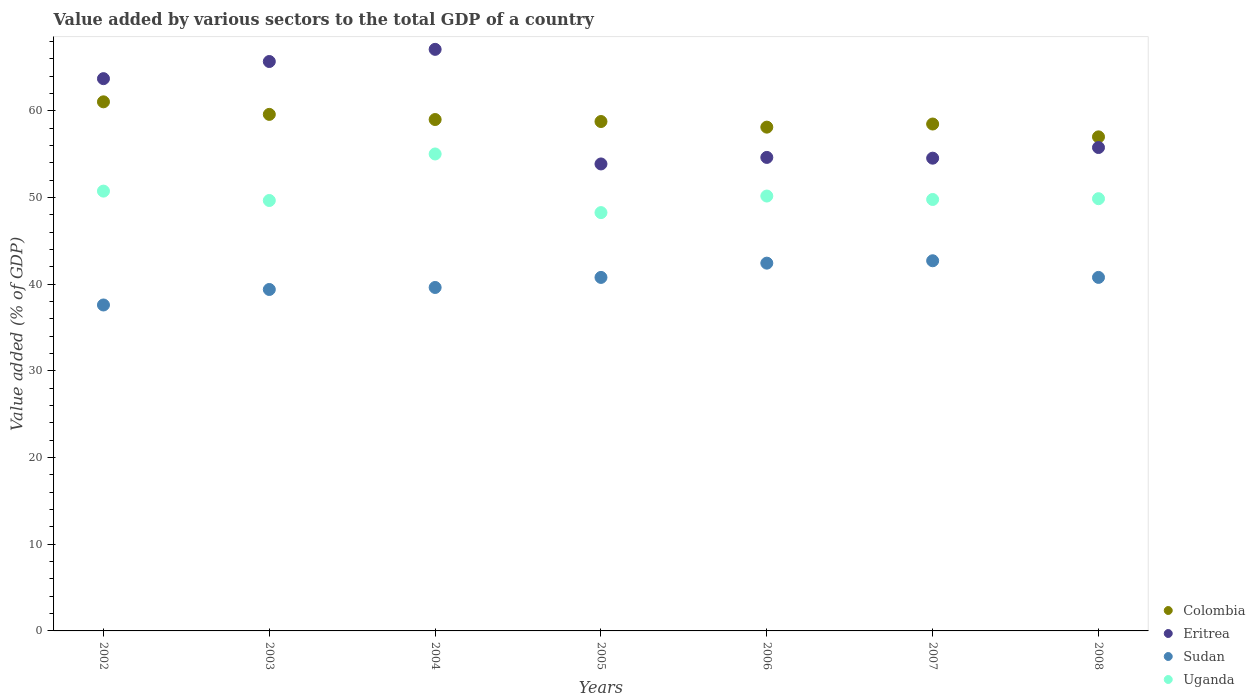How many different coloured dotlines are there?
Ensure brevity in your answer.  4. Is the number of dotlines equal to the number of legend labels?
Ensure brevity in your answer.  Yes. What is the value added by various sectors to the total GDP in Uganda in 2002?
Provide a succinct answer. 50.74. Across all years, what is the maximum value added by various sectors to the total GDP in Sudan?
Keep it short and to the point. 42.7. Across all years, what is the minimum value added by various sectors to the total GDP in Colombia?
Your answer should be very brief. 57. What is the total value added by various sectors to the total GDP in Sudan in the graph?
Your answer should be compact. 283.31. What is the difference between the value added by various sectors to the total GDP in Sudan in 2004 and that in 2006?
Offer a very short reply. -2.81. What is the difference between the value added by various sectors to the total GDP in Eritrea in 2002 and the value added by various sectors to the total GDP in Uganda in 2007?
Offer a very short reply. 13.94. What is the average value added by various sectors to the total GDP in Colombia per year?
Make the answer very short. 58.85. In the year 2007, what is the difference between the value added by various sectors to the total GDP in Sudan and value added by various sectors to the total GDP in Colombia?
Make the answer very short. -15.77. In how many years, is the value added by various sectors to the total GDP in Eritrea greater than 48 %?
Give a very brief answer. 7. What is the ratio of the value added by various sectors to the total GDP in Colombia in 2003 to that in 2005?
Provide a succinct answer. 1.01. Is the difference between the value added by various sectors to the total GDP in Sudan in 2003 and 2007 greater than the difference between the value added by various sectors to the total GDP in Colombia in 2003 and 2007?
Provide a succinct answer. No. What is the difference between the highest and the second highest value added by various sectors to the total GDP in Uganda?
Offer a very short reply. 4.28. What is the difference between the highest and the lowest value added by various sectors to the total GDP in Uganda?
Your answer should be compact. 6.76. Is the sum of the value added by various sectors to the total GDP in Sudan in 2002 and 2004 greater than the maximum value added by various sectors to the total GDP in Colombia across all years?
Your answer should be compact. Yes. Is it the case that in every year, the sum of the value added by various sectors to the total GDP in Colombia and value added by various sectors to the total GDP in Eritrea  is greater than the sum of value added by various sectors to the total GDP in Sudan and value added by various sectors to the total GDP in Uganda?
Provide a succinct answer. No. Is it the case that in every year, the sum of the value added by various sectors to the total GDP in Eritrea and value added by various sectors to the total GDP in Sudan  is greater than the value added by various sectors to the total GDP in Colombia?
Your answer should be very brief. Yes. What is the difference between two consecutive major ticks on the Y-axis?
Provide a short and direct response. 10. Where does the legend appear in the graph?
Offer a terse response. Bottom right. How many legend labels are there?
Provide a short and direct response. 4. How are the legend labels stacked?
Provide a succinct answer. Vertical. What is the title of the graph?
Give a very brief answer. Value added by various sectors to the total GDP of a country. What is the label or title of the Y-axis?
Provide a short and direct response. Value added (% of GDP). What is the Value added (% of GDP) in Colombia in 2002?
Offer a terse response. 61.04. What is the Value added (% of GDP) of Eritrea in 2002?
Offer a terse response. 63.71. What is the Value added (% of GDP) in Sudan in 2002?
Your answer should be very brief. 37.6. What is the Value added (% of GDP) in Uganda in 2002?
Give a very brief answer. 50.74. What is the Value added (% of GDP) in Colombia in 2003?
Ensure brevity in your answer.  59.59. What is the Value added (% of GDP) of Eritrea in 2003?
Offer a terse response. 65.69. What is the Value added (% of GDP) of Sudan in 2003?
Your answer should be compact. 39.39. What is the Value added (% of GDP) of Uganda in 2003?
Offer a very short reply. 49.66. What is the Value added (% of GDP) in Colombia in 2004?
Your answer should be compact. 59. What is the Value added (% of GDP) of Eritrea in 2004?
Make the answer very short. 67.09. What is the Value added (% of GDP) in Sudan in 2004?
Keep it short and to the point. 39.62. What is the Value added (% of GDP) of Uganda in 2004?
Keep it short and to the point. 55.02. What is the Value added (% of GDP) in Colombia in 2005?
Provide a short and direct response. 58.77. What is the Value added (% of GDP) of Eritrea in 2005?
Your response must be concise. 53.87. What is the Value added (% of GDP) of Sudan in 2005?
Provide a short and direct response. 40.78. What is the Value added (% of GDP) in Uganda in 2005?
Keep it short and to the point. 48.26. What is the Value added (% of GDP) of Colombia in 2006?
Your response must be concise. 58.12. What is the Value added (% of GDP) in Eritrea in 2006?
Make the answer very short. 54.63. What is the Value added (% of GDP) of Sudan in 2006?
Provide a short and direct response. 42.43. What is the Value added (% of GDP) in Uganda in 2006?
Your answer should be very brief. 50.17. What is the Value added (% of GDP) in Colombia in 2007?
Keep it short and to the point. 58.48. What is the Value added (% of GDP) of Eritrea in 2007?
Your response must be concise. 54.54. What is the Value added (% of GDP) in Sudan in 2007?
Offer a terse response. 42.7. What is the Value added (% of GDP) in Uganda in 2007?
Your response must be concise. 49.77. What is the Value added (% of GDP) of Colombia in 2008?
Your response must be concise. 57. What is the Value added (% of GDP) of Eritrea in 2008?
Provide a succinct answer. 55.77. What is the Value added (% of GDP) in Sudan in 2008?
Keep it short and to the point. 40.78. What is the Value added (% of GDP) of Uganda in 2008?
Offer a terse response. 49.86. Across all years, what is the maximum Value added (% of GDP) in Colombia?
Your answer should be compact. 61.04. Across all years, what is the maximum Value added (% of GDP) in Eritrea?
Your answer should be compact. 67.09. Across all years, what is the maximum Value added (% of GDP) in Sudan?
Keep it short and to the point. 42.7. Across all years, what is the maximum Value added (% of GDP) of Uganda?
Ensure brevity in your answer.  55.02. Across all years, what is the minimum Value added (% of GDP) of Colombia?
Ensure brevity in your answer.  57. Across all years, what is the minimum Value added (% of GDP) in Eritrea?
Offer a very short reply. 53.87. Across all years, what is the minimum Value added (% of GDP) in Sudan?
Ensure brevity in your answer.  37.6. Across all years, what is the minimum Value added (% of GDP) in Uganda?
Offer a terse response. 48.26. What is the total Value added (% of GDP) in Colombia in the graph?
Offer a terse response. 411.98. What is the total Value added (% of GDP) in Eritrea in the graph?
Provide a short and direct response. 415.29. What is the total Value added (% of GDP) of Sudan in the graph?
Provide a succinct answer. 283.31. What is the total Value added (% of GDP) in Uganda in the graph?
Offer a very short reply. 353.48. What is the difference between the Value added (% of GDP) in Colombia in 2002 and that in 2003?
Provide a short and direct response. 1.45. What is the difference between the Value added (% of GDP) in Eritrea in 2002 and that in 2003?
Provide a succinct answer. -1.98. What is the difference between the Value added (% of GDP) of Sudan in 2002 and that in 2003?
Offer a terse response. -1.79. What is the difference between the Value added (% of GDP) in Uganda in 2002 and that in 2003?
Offer a very short reply. 1.08. What is the difference between the Value added (% of GDP) of Colombia in 2002 and that in 2004?
Provide a succinct answer. 2.04. What is the difference between the Value added (% of GDP) of Eritrea in 2002 and that in 2004?
Provide a succinct answer. -3.38. What is the difference between the Value added (% of GDP) in Sudan in 2002 and that in 2004?
Offer a very short reply. -2.02. What is the difference between the Value added (% of GDP) in Uganda in 2002 and that in 2004?
Your response must be concise. -4.28. What is the difference between the Value added (% of GDP) in Colombia in 2002 and that in 2005?
Offer a terse response. 2.27. What is the difference between the Value added (% of GDP) of Eritrea in 2002 and that in 2005?
Give a very brief answer. 9.84. What is the difference between the Value added (% of GDP) of Sudan in 2002 and that in 2005?
Keep it short and to the point. -3.18. What is the difference between the Value added (% of GDP) in Uganda in 2002 and that in 2005?
Make the answer very short. 2.48. What is the difference between the Value added (% of GDP) in Colombia in 2002 and that in 2006?
Your answer should be compact. 2.92. What is the difference between the Value added (% of GDP) in Eritrea in 2002 and that in 2006?
Provide a short and direct response. 9.09. What is the difference between the Value added (% of GDP) of Sudan in 2002 and that in 2006?
Make the answer very short. -4.83. What is the difference between the Value added (% of GDP) in Uganda in 2002 and that in 2006?
Make the answer very short. 0.57. What is the difference between the Value added (% of GDP) of Colombia in 2002 and that in 2007?
Give a very brief answer. 2.56. What is the difference between the Value added (% of GDP) of Eritrea in 2002 and that in 2007?
Keep it short and to the point. 9.17. What is the difference between the Value added (% of GDP) in Sudan in 2002 and that in 2007?
Make the answer very short. -5.1. What is the difference between the Value added (% of GDP) in Uganda in 2002 and that in 2007?
Your response must be concise. 0.97. What is the difference between the Value added (% of GDP) of Colombia in 2002 and that in 2008?
Ensure brevity in your answer.  4.04. What is the difference between the Value added (% of GDP) of Eritrea in 2002 and that in 2008?
Your response must be concise. 7.95. What is the difference between the Value added (% of GDP) in Sudan in 2002 and that in 2008?
Offer a terse response. -3.18. What is the difference between the Value added (% of GDP) in Uganda in 2002 and that in 2008?
Offer a very short reply. 0.87. What is the difference between the Value added (% of GDP) in Colombia in 2003 and that in 2004?
Offer a very short reply. 0.59. What is the difference between the Value added (% of GDP) in Eritrea in 2003 and that in 2004?
Your answer should be compact. -1.4. What is the difference between the Value added (% of GDP) in Sudan in 2003 and that in 2004?
Make the answer very short. -0.23. What is the difference between the Value added (% of GDP) of Uganda in 2003 and that in 2004?
Provide a short and direct response. -5.37. What is the difference between the Value added (% of GDP) in Colombia in 2003 and that in 2005?
Your response must be concise. 0.82. What is the difference between the Value added (% of GDP) in Eritrea in 2003 and that in 2005?
Keep it short and to the point. 11.82. What is the difference between the Value added (% of GDP) of Sudan in 2003 and that in 2005?
Ensure brevity in your answer.  -1.39. What is the difference between the Value added (% of GDP) in Uganda in 2003 and that in 2005?
Provide a short and direct response. 1.4. What is the difference between the Value added (% of GDP) in Colombia in 2003 and that in 2006?
Make the answer very short. 1.47. What is the difference between the Value added (% of GDP) of Eritrea in 2003 and that in 2006?
Offer a very short reply. 11.06. What is the difference between the Value added (% of GDP) in Sudan in 2003 and that in 2006?
Your response must be concise. -3.04. What is the difference between the Value added (% of GDP) in Uganda in 2003 and that in 2006?
Keep it short and to the point. -0.51. What is the difference between the Value added (% of GDP) of Colombia in 2003 and that in 2007?
Give a very brief answer. 1.11. What is the difference between the Value added (% of GDP) in Eritrea in 2003 and that in 2007?
Your response must be concise. 11.15. What is the difference between the Value added (% of GDP) of Sudan in 2003 and that in 2007?
Provide a succinct answer. -3.31. What is the difference between the Value added (% of GDP) in Uganda in 2003 and that in 2007?
Provide a succinct answer. -0.12. What is the difference between the Value added (% of GDP) of Colombia in 2003 and that in 2008?
Provide a short and direct response. 2.59. What is the difference between the Value added (% of GDP) of Eritrea in 2003 and that in 2008?
Provide a succinct answer. 9.92. What is the difference between the Value added (% of GDP) in Sudan in 2003 and that in 2008?
Make the answer very short. -1.39. What is the difference between the Value added (% of GDP) in Uganda in 2003 and that in 2008?
Offer a very short reply. -0.21. What is the difference between the Value added (% of GDP) of Colombia in 2004 and that in 2005?
Provide a succinct answer. 0.23. What is the difference between the Value added (% of GDP) of Eritrea in 2004 and that in 2005?
Keep it short and to the point. 13.22. What is the difference between the Value added (% of GDP) in Sudan in 2004 and that in 2005?
Provide a succinct answer. -1.16. What is the difference between the Value added (% of GDP) of Uganda in 2004 and that in 2005?
Give a very brief answer. 6.76. What is the difference between the Value added (% of GDP) of Colombia in 2004 and that in 2006?
Your response must be concise. 0.88. What is the difference between the Value added (% of GDP) of Eritrea in 2004 and that in 2006?
Offer a very short reply. 12.47. What is the difference between the Value added (% of GDP) of Sudan in 2004 and that in 2006?
Keep it short and to the point. -2.81. What is the difference between the Value added (% of GDP) of Uganda in 2004 and that in 2006?
Ensure brevity in your answer.  4.85. What is the difference between the Value added (% of GDP) of Colombia in 2004 and that in 2007?
Your answer should be compact. 0.52. What is the difference between the Value added (% of GDP) of Eritrea in 2004 and that in 2007?
Give a very brief answer. 12.55. What is the difference between the Value added (% of GDP) of Sudan in 2004 and that in 2007?
Your response must be concise. -3.08. What is the difference between the Value added (% of GDP) of Uganda in 2004 and that in 2007?
Your answer should be compact. 5.25. What is the difference between the Value added (% of GDP) of Colombia in 2004 and that in 2008?
Your response must be concise. 2. What is the difference between the Value added (% of GDP) of Eritrea in 2004 and that in 2008?
Provide a succinct answer. 11.32. What is the difference between the Value added (% of GDP) in Sudan in 2004 and that in 2008?
Offer a terse response. -1.16. What is the difference between the Value added (% of GDP) of Uganda in 2004 and that in 2008?
Your answer should be very brief. 5.16. What is the difference between the Value added (% of GDP) of Colombia in 2005 and that in 2006?
Your answer should be very brief. 0.65. What is the difference between the Value added (% of GDP) in Eritrea in 2005 and that in 2006?
Provide a short and direct response. -0.75. What is the difference between the Value added (% of GDP) in Sudan in 2005 and that in 2006?
Give a very brief answer. -1.65. What is the difference between the Value added (% of GDP) of Uganda in 2005 and that in 2006?
Give a very brief answer. -1.91. What is the difference between the Value added (% of GDP) in Colombia in 2005 and that in 2007?
Offer a very short reply. 0.29. What is the difference between the Value added (% of GDP) in Eritrea in 2005 and that in 2007?
Your answer should be very brief. -0.67. What is the difference between the Value added (% of GDP) of Sudan in 2005 and that in 2007?
Provide a succinct answer. -1.92. What is the difference between the Value added (% of GDP) of Uganda in 2005 and that in 2007?
Ensure brevity in your answer.  -1.52. What is the difference between the Value added (% of GDP) in Colombia in 2005 and that in 2008?
Provide a succinct answer. 1.77. What is the difference between the Value added (% of GDP) of Eritrea in 2005 and that in 2008?
Ensure brevity in your answer.  -1.89. What is the difference between the Value added (% of GDP) in Sudan in 2005 and that in 2008?
Ensure brevity in your answer.  -0. What is the difference between the Value added (% of GDP) of Uganda in 2005 and that in 2008?
Offer a very short reply. -1.61. What is the difference between the Value added (% of GDP) of Colombia in 2006 and that in 2007?
Provide a short and direct response. -0.36. What is the difference between the Value added (% of GDP) in Eritrea in 2006 and that in 2007?
Your answer should be very brief. 0.09. What is the difference between the Value added (% of GDP) of Sudan in 2006 and that in 2007?
Make the answer very short. -0.27. What is the difference between the Value added (% of GDP) of Uganda in 2006 and that in 2007?
Your answer should be compact. 0.4. What is the difference between the Value added (% of GDP) in Colombia in 2006 and that in 2008?
Your response must be concise. 1.12. What is the difference between the Value added (% of GDP) of Eritrea in 2006 and that in 2008?
Offer a very short reply. -1.14. What is the difference between the Value added (% of GDP) of Sudan in 2006 and that in 2008?
Provide a succinct answer. 1.64. What is the difference between the Value added (% of GDP) of Uganda in 2006 and that in 2008?
Your response must be concise. 0.31. What is the difference between the Value added (% of GDP) of Colombia in 2007 and that in 2008?
Offer a very short reply. 1.48. What is the difference between the Value added (% of GDP) of Eritrea in 2007 and that in 2008?
Your answer should be very brief. -1.23. What is the difference between the Value added (% of GDP) of Sudan in 2007 and that in 2008?
Offer a terse response. 1.92. What is the difference between the Value added (% of GDP) in Uganda in 2007 and that in 2008?
Provide a succinct answer. -0.09. What is the difference between the Value added (% of GDP) of Colombia in 2002 and the Value added (% of GDP) of Eritrea in 2003?
Provide a short and direct response. -4.65. What is the difference between the Value added (% of GDP) of Colombia in 2002 and the Value added (% of GDP) of Sudan in 2003?
Make the answer very short. 21.65. What is the difference between the Value added (% of GDP) of Colombia in 2002 and the Value added (% of GDP) of Uganda in 2003?
Make the answer very short. 11.38. What is the difference between the Value added (% of GDP) in Eritrea in 2002 and the Value added (% of GDP) in Sudan in 2003?
Provide a short and direct response. 24.32. What is the difference between the Value added (% of GDP) of Eritrea in 2002 and the Value added (% of GDP) of Uganda in 2003?
Your response must be concise. 14.06. What is the difference between the Value added (% of GDP) of Sudan in 2002 and the Value added (% of GDP) of Uganda in 2003?
Your answer should be compact. -12.05. What is the difference between the Value added (% of GDP) of Colombia in 2002 and the Value added (% of GDP) of Eritrea in 2004?
Your answer should be compact. -6.05. What is the difference between the Value added (% of GDP) in Colombia in 2002 and the Value added (% of GDP) in Sudan in 2004?
Keep it short and to the point. 21.42. What is the difference between the Value added (% of GDP) of Colombia in 2002 and the Value added (% of GDP) of Uganda in 2004?
Your answer should be very brief. 6.02. What is the difference between the Value added (% of GDP) of Eritrea in 2002 and the Value added (% of GDP) of Sudan in 2004?
Make the answer very short. 24.09. What is the difference between the Value added (% of GDP) of Eritrea in 2002 and the Value added (% of GDP) of Uganda in 2004?
Give a very brief answer. 8.69. What is the difference between the Value added (% of GDP) in Sudan in 2002 and the Value added (% of GDP) in Uganda in 2004?
Make the answer very short. -17.42. What is the difference between the Value added (% of GDP) of Colombia in 2002 and the Value added (% of GDP) of Eritrea in 2005?
Ensure brevity in your answer.  7.17. What is the difference between the Value added (% of GDP) of Colombia in 2002 and the Value added (% of GDP) of Sudan in 2005?
Provide a succinct answer. 20.26. What is the difference between the Value added (% of GDP) of Colombia in 2002 and the Value added (% of GDP) of Uganda in 2005?
Your response must be concise. 12.78. What is the difference between the Value added (% of GDP) of Eritrea in 2002 and the Value added (% of GDP) of Sudan in 2005?
Your answer should be compact. 22.93. What is the difference between the Value added (% of GDP) of Eritrea in 2002 and the Value added (% of GDP) of Uganda in 2005?
Keep it short and to the point. 15.45. What is the difference between the Value added (% of GDP) in Sudan in 2002 and the Value added (% of GDP) in Uganda in 2005?
Your answer should be compact. -10.66. What is the difference between the Value added (% of GDP) in Colombia in 2002 and the Value added (% of GDP) in Eritrea in 2006?
Keep it short and to the point. 6.41. What is the difference between the Value added (% of GDP) of Colombia in 2002 and the Value added (% of GDP) of Sudan in 2006?
Provide a succinct answer. 18.61. What is the difference between the Value added (% of GDP) of Colombia in 2002 and the Value added (% of GDP) of Uganda in 2006?
Provide a short and direct response. 10.87. What is the difference between the Value added (% of GDP) of Eritrea in 2002 and the Value added (% of GDP) of Sudan in 2006?
Provide a short and direct response. 21.28. What is the difference between the Value added (% of GDP) of Eritrea in 2002 and the Value added (% of GDP) of Uganda in 2006?
Your answer should be compact. 13.54. What is the difference between the Value added (% of GDP) in Sudan in 2002 and the Value added (% of GDP) in Uganda in 2006?
Provide a succinct answer. -12.57. What is the difference between the Value added (% of GDP) of Colombia in 2002 and the Value added (% of GDP) of Eritrea in 2007?
Provide a succinct answer. 6.5. What is the difference between the Value added (% of GDP) of Colombia in 2002 and the Value added (% of GDP) of Sudan in 2007?
Your response must be concise. 18.34. What is the difference between the Value added (% of GDP) of Colombia in 2002 and the Value added (% of GDP) of Uganda in 2007?
Keep it short and to the point. 11.27. What is the difference between the Value added (% of GDP) in Eritrea in 2002 and the Value added (% of GDP) in Sudan in 2007?
Provide a succinct answer. 21.01. What is the difference between the Value added (% of GDP) in Eritrea in 2002 and the Value added (% of GDP) in Uganda in 2007?
Offer a terse response. 13.94. What is the difference between the Value added (% of GDP) of Sudan in 2002 and the Value added (% of GDP) of Uganda in 2007?
Your response must be concise. -12.17. What is the difference between the Value added (% of GDP) in Colombia in 2002 and the Value added (% of GDP) in Eritrea in 2008?
Make the answer very short. 5.27. What is the difference between the Value added (% of GDP) in Colombia in 2002 and the Value added (% of GDP) in Sudan in 2008?
Provide a succinct answer. 20.25. What is the difference between the Value added (% of GDP) of Colombia in 2002 and the Value added (% of GDP) of Uganda in 2008?
Provide a succinct answer. 11.17. What is the difference between the Value added (% of GDP) in Eritrea in 2002 and the Value added (% of GDP) in Sudan in 2008?
Give a very brief answer. 22.93. What is the difference between the Value added (% of GDP) in Eritrea in 2002 and the Value added (% of GDP) in Uganda in 2008?
Provide a short and direct response. 13.85. What is the difference between the Value added (% of GDP) of Sudan in 2002 and the Value added (% of GDP) of Uganda in 2008?
Provide a succinct answer. -12.26. What is the difference between the Value added (% of GDP) of Colombia in 2003 and the Value added (% of GDP) of Eritrea in 2004?
Your response must be concise. -7.5. What is the difference between the Value added (% of GDP) in Colombia in 2003 and the Value added (% of GDP) in Sudan in 2004?
Your answer should be compact. 19.97. What is the difference between the Value added (% of GDP) of Colombia in 2003 and the Value added (% of GDP) of Uganda in 2004?
Your answer should be very brief. 4.57. What is the difference between the Value added (% of GDP) of Eritrea in 2003 and the Value added (% of GDP) of Sudan in 2004?
Your response must be concise. 26.07. What is the difference between the Value added (% of GDP) of Eritrea in 2003 and the Value added (% of GDP) of Uganda in 2004?
Ensure brevity in your answer.  10.67. What is the difference between the Value added (% of GDP) of Sudan in 2003 and the Value added (% of GDP) of Uganda in 2004?
Your answer should be very brief. -15.63. What is the difference between the Value added (% of GDP) of Colombia in 2003 and the Value added (% of GDP) of Eritrea in 2005?
Make the answer very short. 5.72. What is the difference between the Value added (% of GDP) of Colombia in 2003 and the Value added (% of GDP) of Sudan in 2005?
Your answer should be very brief. 18.81. What is the difference between the Value added (% of GDP) in Colombia in 2003 and the Value added (% of GDP) in Uganda in 2005?
Your answer should be very brief. 11.33. What is the difference between the Value added (% of GDP) of Eritrea in 2003 and the Value added (% of GDP) of Sudan in 2005?
Provide a short and direct response. 24.91. What is the difference between the Value added (% of GDP) of Eritrea in 2003 and the Value added (% of GDP) of Uganda in 2005?
Ensure brevity in your answer.  17.43. What is the difference between the Value added (% of GDP) of Sudan in 2003 and the Value added (% of GDP) of Uganda in 2005?
Offer a terse response. -8.87. What is the difference between the Value added (% of GDP) of Colombia in 2003 and the Value added (% of GDP) of Eritrea in 2006?
Provide a succinct answer. 4.96. What is the difference between the Value added (% of GDP) in Colombia in 2003 and the Value added (% of GDP) in Sudan in 2006?
Provide a succinct answer. 17.16. What is the difference between the Value added (% of GDP) in Colombia in 2003 and the Value added (% of GDP) in Uganda in 2006?
Ensure brevity in your answer.  9.42. What is the difference between the Value added (% of GDP) of Eritrea in 2003 and the Value added (% of GDP) of Sudan in 2006?
Make the answer very short. 23.26. What is the difference between the Value added (% of GDP) in Eritrea in 2003 and the Value added (% of GDP) in Uganda in 2006?
Keep it short and to the point. 15.52. What is the difference between the Value added (% of GDP) in Sudan in 2003 and the Value added (% of GDP) in Uganda in 2006?
Give a very brief answer. -10.78. What is the difference between the Value added (% of GDP) of Colombia in 2003 and the Value added (% of GDP) of Eritrea in 2007?
Provide a succinct answer. 5.05. What is the difference between the Value added (% of GDP) of Colombia in 2003 and the Value added (% of GDP) of Sudan in 2007?
Your answer should be very brief. 16.89. What is the difference between the Value added (% of GDP) in Colombia in 2003 and the Value added (% of GDP) in Uganda in 2007?
Provide a short and direct response. 9.82. What is the difference between the Value added (% of GDP) in Eritrea in 2003 and the Value added (% of GDP) in Sudan in 2007?
Offer a very short reply. 22.99. What is the difference between the Value added (% of GDP) of Eritrea in 2003 and the Value added (% of GDP) of Uganda in 2007?
Keep it short and to the point. 15.92. What is the difference between the Value added (% of GDP) in Sudan in 2003 and the Value added (% of GDP) in Uganda in 2007?
Provide a succinct answer. -10.38. What is the difference between the Value added (% of GDP) in Colombia in 2003 and the Value added (% of GDP) in Eritrea in 2008?
Ensure brevity in your answer.  3.82. What is the difference between the Value added (% of GDP) in Colombia in 2003 and the Value added (% of GDP) in Sudan in 2008?
Give a very brief answer. 18.81. What is the difference between the Value added (% of GDP) of Colombia in 2003 and the Value added (% of GDP) of Uganda in 2008?
Provide a short and direct response. 9.73. What is the difference between the Value added (% of GDP) of Eritrea in 2003 and the Value added (% of GDP) of Sudan in 2008?
Provide a short and direct response. 24.91. What is the difference between the Value added (% of GDP) of Eritrea in 2003 and the Value added (% of GDP) of Uganda in 2008?
Ensure brevity in your answer.  15.83. What is the difference between the Value added (% of GDP) in Sudan in 2003 and the Value added (% of GDP) in Uganda in 2008?
Offer a very short reply. -10.47. What is the difference between the Value added (% of GDP) in Colombia in 2004 and the Value added (% of GDP) in Eritrea in 2005?
Offer a very short reply. 5.12. What is the difference between the Value added (% of GDP) in Colombia in 2004 and the Value added (% of GDP) in Sudan in 2005?
Provide a short and direct response. 18.22. What is the difference between the Value added (% of GDP) in Colombia in 2004 and the Value added (% of GDP) in Uganda in 2005?
Your answer should be compact. 10.74. What is the difference between the Value added (% of GDP) of Eritrea in 2004 and the Value added (% of GDP) of Sudan in 2005?
Your response must be concise. 26.31. What is the difference between the Value added (% of GDP) of Eritrea in 2004 and the Value added (% of GDP) of Uganda in 2005?
Ensure brevity in your answer.  18.83. What is the difference between the Value added (% of GDP) in Sudan in 2004 and the Value added (% of GDP) in Uganda in 2005?
Offer a very short reply. -8.64. What is the difference between the Value added (% of GDP) in Colombia in 2004 and the Value added (% of GDP) in Eritrea in 2006?
Keep it short and to the point. 4.37. What is the difference between the Value added (% of GDP) of Colombia in 2004 and the Value added (% of GDP) of Sudan in 2006?
Your response must be concise. 16.57. What is the difference between the Value added (% of GDP) of Colombia in 2004 and the Value added (% of GDP) of Uganda in 2006?
Your answer should be very brief. 8.83. What is the difference between the Value added (% of GDP) in Eritrea in 2004 and the Value added (% of GDP) in Sudan in 2006?
Ensure brevity in your answer.  24.66. What is the difference between the Value added (% of GDP) of Eritrea in 2004 and the Value added (% of GDP) of Uganda in 2006?
Make the answer very short. 16.92. What is the difference between the Value added (% of GDP) in Sudan in 2004 and the Value added (% of GDP) in Uganda in 2006?
Offer a very short reply. -10.55. What is the difference between the Value added (% of GDP) in Colombia in 2004 and the Value added (% of GDP) in Eritrea in 2007?
Your answer should be compact. 4.46. What is the difference between the Value added (% of GDP) of Colombia in 2004 and the Value added (% of GDP) of Sudan in 2007?
Offer a terse response. 16.29. What is the difference between the Value added (% of GDP) of Colombia in 2004 and the Value added (% of GDP) of Uganda in 2007?
Provide a succinct answer. 9.22. What is the difference between the Value added (% of GDP) in Eritrea in 2004 and the Value added (% of GDP) in Sudan in 2007?
Give a very brief answer. 24.39. What is the difference between the Value added (% of GDP) in Eritrea in 2004 and the Value added (% of GDP) in Uganda in 2007?
Your answer should be compact. 17.32. What is the difference between the Value added (% of GDP) in Sudan in 2004 and the Value added (% of GDP) in Uganda in 2007?
Your response must be concise. -10.15. What is the difference between the Value added (% of GDP) of Colombia in 2004 and the Value added (% of GDP) of Eritrea in 2008?
Your answer should be very brief. 3.23. What is the difference between the Value added (% of GDP) of Colombia in 2004 and the Value added (% of GDP) of Sudan in 2008?
Make the answer very short. 18.21. What is the difference between the Value added (% of GDP) in Colombia in 2004 and the Value added (% of GDP) in Uganda in 2008?
Offer a very short reply. 9.13. What is the difference between the Value added (% of GDP) of Eritrea in 2004 and the Value added (% of GDP) of Sudan in 2008?
Your answer should be compact. 26.31. What is the difference between the Value added (% of GDP) in Eritrea in 2004 and the Value added (% of GDP) in Uganda in 2008?
Make the answer very short. 17.23. What is the difference between the Value added (% of GDP) in Sudan in 2004 and the Value added (% of GDP) in Uganda in 2008?
Offer a very short reply. -10.24. What is the difference between the Value added (% of GDP) of Colombia in 2005 and the Value added (% of GDP) of Eritrea in 2006?
Offer a very short reply. 4.14. What is the difference between the Value added (% of GDP) of Colombia in 2005 and the Value added (% of GDP) of Sudan in 2006?
Offer a terse response. 16.34. What is the difference between the Value added (% of GDP) of Colombia in 2005 and the Value added (% of GDP) of Uganda in 2006?
Your answer should be very brief. 8.6. What is the difference between the Value added (% of GDP) in Eritrea in 2005 and the Value added (% of GDP) in Sudan in 2006?
Provide a succinct answer. 11.44. What is the difference between the Value added (% of GDP) in Eritrea in 2005 and the Value added (% of GDP) in Uganda in 2006?
Offer a very short reply. 3.7. What is the difference between the Value added (% of GDP) in Sudan in 2005 and the Value added (% of GDP) in Uganda in 2006?
Give a very brief answer. -9.39. What is the difference between the Value added (% of GDP) in Colombia in 2005 and the Value added (% of GDP) in Eritrea in 2007?
Ensure brevity in your answer.  4.23. What is the difference between the Value added (% of GDP) in Colombia in 2005 and the Value added (% of GDP) in Sudan in 2007?
Offer a terse response. 16.06. What is the difference between the Value added (% of GDP) of Colombia in 2005 and the Value added (% of GDP) of Uganda in 2007?
Your response must be concise. 8.99. What is the difference between the Value added (% of GDP) of Eritrea in 2005 and the Value added (% of GDP) of Sudan in 2007?
Your answer should be compact. 11.17. What is the difference between the Value added (% of GDP) of Eritrea in 2005 and the Value added (% of GDP) of Uganda in 2007?
Provide a short and direct response. 4.1. What is the difference between the Value added (% of GDP) of Sudan in 2005 and the Value added (% of GDP) of Uganda in 2007?
Make the answer very short. -8.99. What is the difference between the Value added (% of GDP) in Colombia in 2005 and the Value added (% of GDP) in Eritrea in 2008?
Offer a very short reply. 3. What is the difference between the Value added (% of GDP) in Colombia in 2005 and the Value added (% of GDP) in Sudan in 2008?
Your answer should be compact. 17.98. What is the difference between the Value added (% of GDP) in Colombia in 2005 and the Value added (% of GDP) in Uganda in 2008?
Give a very brief answer. 8.9. What is the difference between the Value added (% of GDP) in Eritrea in 2005 and the Value added (% of GDP) in Sudan in 2008?
Make the answer very short. 13.09. What is the difference between the Value added (% of GDP) of Eritrea in 2005 and the Value added (% of GDP) of Uganda in 2008?
Give a very brief answer. 4.01. What is the difference between the Value added (% of GDP) in Sudan in 2005 and the Value added (% of GDP) in Uganda in 2008?
Ensure brevity in your answer.  -9.08. What is the difference between the Value added (% of GDP) of Colombia in 2006 and the Value added (% of GDP) of Eritrea in 2007?
Your answer should be compact. 3.58. What is the difference between the Value added (% of GDP) in Colombia in 2006 and the Value added (% of GDP) in Sudan in 2007?
Your answer should be compact. 15.41. What is the difference between the Value added (% of GDP) of Colombia in 2006 and the Value added (% of GDP) of Uganda in 2007?
Give a very brief answer. 8.35. What is the difference between the Value added (% of GDP) of Eritrea in 2006 and the Value added (% of GDP) of Sudan in 2007?
Provide a succinct answer. 11.92. What is the difference between the Value added (% of GDP) of Eritrea in 2006 and the Value added (% of GDP) of Uganda in 2007?
Keep it short and to the point. 4.85. What is the difference between the Value added (% of GDP) in Sudan in 2006 and the Value added (% of GDP) in Uganda in 2007?
Provide a succinct answer. -7.34. What is the difference between the Value added (% of GDP) in Colombia in 2006 and the Value added (% of GDP) in Eritrea in 2008?
Your response must be concise. 2.35. What is the difference between the Value added (% of GDP) in Colombia in 2006 and the Value added (% of GDP) in Sudan in 2008?
Give a very brief answer. 17.33. What is the difference between the Value added (% of GDP) in Colombia in 2006 and the Value added (% of GDP) in Uganda in 2008?
Give a very brief answer. 8.25. What is the difference between the Value added (% of GDP) of Eritrea in 2006 and the Value added (% of GDP) of Sudan in 2008?
Make the answer very short. 13.84. What is the difference between the Value added (% of GDP) in Eritrea in 2006 and the Value added (% of GDP) in Uganda in 2008?
Your answer should be compact. 4.76. What is the difference between the Value added (% of GDP) of Sudan in 2006 and the Value added (% of GDP) of Uganda in 2008?
Your answer should be very brief. -7.44. What is the difference between the Value added (% of GDP) of Colombia in 2007 and the Value added (% of GDP) of Eritrea in 2008?
Your response must be concise. 2.71. What is the difference between the Value added (% of GDP) of Colombia in 2007 and the Value added (% of GDP) of Sudan in 2008?
Offer a very short reply. 17.69. What is the difference between the Value added (% of GDP) in Colombia in 2007 and the Value added (% of GDP) in Uganda in 2008?
Offer a very short reply. 8.61. What is the difference between the Value added (% of GDP) of Eritrea in 2007 and the Value added (% of GDP) of Sudan in 2008?
Make the answer very short. 13.75. What is the difference between the Value added (% of GDP) of Eritrea in 2007 and the Value added (% of GDP) of Uganda in 2008?
Your response must be concise. 4.67. What is the difference between the Value added (% of GDP) of Sudan in 2007 and the Value added (% of GDP) of Uganda in 2008?
Your response must be concise. -7.16. What is the average Value added (% of GDP) of Colombia per year?
Your response must be concise. 58.85. What is the average Value added (% of GDP) in Eritrea per year?
Ensure brevity in your answer.  59.33. What is the average Value added (% of GDP) in Sudan per year?
Provide a succinct answer. 40.47. What is the average Value added (% of GDP) in Uganda per year?
Your response must be concise. 50.5. In the year 2002, what is the difference between the Value added (% of GDP) in Colombia and Value added (% of GDP) in Eritrea?
Offer a terse response. -2.67. In the year 2002, what is the difference between the Value added (% of GDP) in Colombia and Value added (% of GDP) in Sudan?
Provide a succinct answer. 23.44. In the year 2002, what is the difference between the Value added (% of GDP) of Colombia and Value added (% of GDP) of Uganda?
Your answer should be compact. 10.3. In the year 2002, what is the difference between the Value added (% of GDP) in Eritrea and Value added (% of GDP) in Sudan?
Provide a short and direct response. 26.11. In the year 2002, what is the difference between the Value added (% of GDP) of Eritrea and Value added (% of GDP) of Uganda?
Give a very brief answer. 12.97. In the year 2002, what is the difference between the Value added (% of GDP) of Sudan and Value added (% of GDP) of Uganda?
Ensure brevity in your answer.  -13.14. In the year 2003, what is the difference between the Value added (% of GDP) in Colombia and Value added (% of GDP) in Eritrea?
Provide a succinct answer. -6.1. In the year 2003, what is the difference between the Value added (% of GDP) of Colombia and Value added (% of GDP) of Sudan?
Your answer should be compact. 20.2. In the year 2003, what is the difference between the Value added (% of GDP) in Colombia and Value added (% of GDP) in Uganda?
Keep it short and to the point. 9.93. In the year 2003, what is the difference between the Value added (% of GDP) in Eritrea and Value added (% of GDP) in Sudan?
Ensure brevity in your answer.  26.3. In the year 2003, what is the difference between the Value added (% of GDP) in Eritrea and Value added (% of GDP) in Uganda?
Offer a very short reply. 16.03. In the year 2003, what is the difference between the Value added (% of GDP) of Sudan and Value added (% of GDP) of Uganda?
Provide a succinct answer. -10.27. In the year 2004, what is the difference between the Value added (% of GDP) of Colombia and Value added (% of GDP) of Eritrea?
Your answer should be compact. -8.09. In the year 2004, what is the difference between the Value added (% of GDP) of Colombia and Value added (% of GDP) of Sudan?
Offer a very short reply. 19.38. In the year 2004, what is the difference between the Value added (% of GDP) in Colombia and Value added (% of GDP) in Uganda?
Offer a terse response. 3.97. In the year 2004, what is the difference between the Value added (% of GDP) in Eritrea and Value added (% of GDP) in Sudan?
Make the answer very short. 27.47. In the year 2004, what is the difference between the Value added (% of GDP) of Eritrea and Value added (% of GDP) of Uganda?
Your response must be concise. 12.07. In the year 2004, what is the difference between the Value added (% of GDP) in Sudan and Value added (% of GDP) in Uganda?
Ensure brevity in your answer.  -15.4. In the year 2005, what is the difference between the Value added (% of GDP) in Colombia and Value added (% of GDP) in Eritrea?
Your answer should be compact. 4.89. In the year 2005, what is the difference between the Value added (% of GDP) in Colombia and Value added (% of GDP) in Sudan?
Your response must be concise. 17.98. In the year 2005, what is the difference between the Value added (% of GDP) in Colombia and Value added (% of GDP) in Uganda?
Provide a short and direct response. 10.51. In the year 2005, what is the difference between the Value added (% of GDP) in Eritrea and Value added (% of GDP) in Sudan?
Your response must be concise. 13.09. In the year 2005, what is the difference between the Value added (% of GDP) of Eritrea and Value added (% of GDP) of Uganda?
Keep it short and to the point. 5.61. In the year 2005, what is the difference between the Value added (% of GDP) of Sudan and Value added (% of GDP) of Uganda?
Your answer should be very brief. -7.48. In the year 2006, what is the difference between the Value added (% of GDP) in Colombia and Value added (% of GDP) in Eritrea?
Your response must be concise. 3.49. In the year 2006, what is the difference between the Value added (% of GDP) of Colombia and Value added (% of GDP) of Sudan?
Make the answer very short. 15.69. In the year 2006, what is the difference between the Value added (% of GDP) of Colombia and Value added (% of GDP) of Uganda?
Make the answer very short. 7.95. In the year 2006, what is the difference between the Value added (% of GDP) in Eritrea and Value added (% of GDP) in Sudan?
Give a very brief answer. 12.2. In the year 2006, what is the difference between the Value added (% of GDP) of Eritrea and Value added (% of GDP) of Uganda?
Your answer should be compact. 4.46. In the year 2006, what is the difference between the Value added (% of GDP) of Sudan and Value added (% of GDP) of Uganda?
Offer a terse response. -7.74. In the year 2007, what is the difference between the Value added (% of GDP) of Colombia and Value added (% of GDP) of Eritrea?
Provide a succinct answer. 3.94. In the year 2007, what is the difference between the Value added (% of GDP) of Colombia and Value added (% of GDP) of Sudan?
Provide a short and direct response. 15.77. In the year 2007, what is the difference between the Value added (% of GDP) of Colombia and Value added (% of GDP) of Uganda?
Make the answer very short. 8.71. In the year 2007, what is the difference between the Value added (% of GDP) in Eritrea and Value added (% of GDP) in Sudan?
Provide a succinct answer. 11.83. In the year 2007, what is the difference between the Value added (% of GDP) in Eritrea and Value added (% of GDP) in Uganda?
Give a very brief answer. 4.77. In the year 2007, what is the difference between the Value added (% of GDP) of Sudan and Value added (% of GDP) of Uganda?
Keep it short and to the point. -7.07. In the year 2008, what is the difference between the Value added (% of GDP) of Colombia and Value added (% of GDP) of Eritrea?
Your answer should be very brief. 1.23. In the year 2008, what is the difference between the Value added (% of GDP) of Colombia and Value added (% of GDP) of Sudan?
Make the answer very short. 16.21. In the year 2008, what is the difference between the Value added (% of GDP) in Colombia and Value added (% of GDP) in Uganda?
Provide a short and direct response. 7.13. In the year 2008, what is the difference between the Value added (% of GDP) in Eritrea and Value added (% of GDP) in Sudan?
Make the answer very short. 14.98. In the year 2008, what is the difference between the Value added (% of GDP) in Eritrea and Value added (% of GDP) in Uganda?
Your response must be concise. 5.9. In the year 2008, what is the difference between the Value added (% of GDP) in Sudan and Value added (% of GDP) in Uganda?
Your response must be concise. -9.08. What is the ratio of the Value added (% of GDP) of Colombia in 2002 to that in 2003?
Offer a terse response. 1.02. What is the ratio of the Value added (% of GDP) of Eritrea in 2002 to that in 2003?
Ensure brevity in your answer.  0.97. What is the ratio of the Value added (% of GDP) in Sudan in 2002 to that in 2003?
Provide a short and direct response. 0.95. What is the ratio of the Value added (% of GDP) of Uganda in 2002 to that in 2003?
Provide a succinct answer. 1.02. What is the ratio of the Value added (% of GDP) of Colombia in 2002 to that in 2004?
Your response must be concise. 1.03. What is the ratio of the Value added (% of GDP) in Eritrea in 2002 to that in 2004?
Ensure brevity in your answer.  0.95. What is the ratio of the Value added (% of GDP) in Sudan in 2002 to that in 2004?
Provide a succinct answer. 0.95. What is the ratio of the Value added (% of GDP) in Uganda in 2002 to that in 2004?
Your answer should be very brief. 0.92. What is the ratio of the Value added (% of GDP) of Colombia in 2002 to that in 2005?
Provide a succinct answer. 1.04. What is the ratio of the Value added (% of GDP) in Eritrea in 2002 to that in 2005?
Provide a short and direct response. 1.18. What is the ratio of the Value added (% of GDP) in Sudan in 2002 to that in 2005?
Your response must be concise. 0.92. What is the ratio of the Value added (% of GDP) in Uganda in 2002 to that in 2005?
Make the answer very short. 1.05. What is the ratio of the Value added (% of GDP) in Colombia in 2002 to that in 2006?
Make the answer very short. 1.05. What is the ratio of the Value added (% of GDP) in Eritrea in 2002 to that in 2006?
Provide a short and direct response. 1.17. What is the ratio of the Value added (% of GDP) of Sudan in 2002 to that in 2006?
Make the answer very short. 0.89. What is the ratio of the Value added (% of GDP) in Uganda in 2002 to that in 2006?
Your response must be concise. 1.01. What is the ratio of the Value added (% of GDP) of Colombia in 2002 to that in 2007?
Make the answer very short. 1.04. What is the ratio of the Value added (% of GDP) of Eritrea in 2002 to that in 2007?
Ensure brevity in your answer.  1.17. What is the ratio of the Value added (% of GDP) of Sudan in 2002 to that in 2007?
Your answer should be compact. 0.88. What is the ratio of the Value added (% of GDP) in Uganda in 2002 to that in 2007?
Make the answer very short. 1.02. What is the ratio of the Value added (% of GDP) in Colombia in 2002 to that in 2008?
Provide a succinct answer. 1.07. What is the ratio of the Value added (% of GDP) of Eritrea in 2002 to that in 2008?
Provide a succinct answer. 1.14. What is the ratio of the Value added (% of GDP) in Sudan in 2002 to that in 2008?
Provide a succinct answer. 0.92. What is the ratio of the Value added (% of GDP) in Uganda in 2002 to that in 2008?
Provide a short and direct response. 1.02. What is the ratio of the Value added (% of GDP) in Eritrea in 2003 to that in 2004?
Your response must be concise. 0.98. What is the ratio of the Value added (% of GDP) in Sudan in 2003 to that in 2004?
Provide a short and direct response. 0.99. What is the ratio of the Value added (% of GDP) of Uganda in 2003 to that in 2004?
Your answer should be very brief. 0.9. What is the ratio of the Value added (% of GDP) of Eritrea in 2003 to that in 2005?
Your response must be concise. 1.22. What is the ratio of the Value added (% of GDP) of Sudan in 2003 to that in 2005?
Provide a succinct answer. 0.97. What is the ratio of the Value added (% of GDP) in Uganda in 2003 to that in 2005?
Ensure brevity in your answer.  1.03. What is the ratio of the Value added (% of GDP) of Colombia in 2003 to that in 2006?
Offer a terse response. 1.03. What is the ratio of the Value added (% of GDP) of Eritrea in 2003 to that in 2006?
Ensure brevity in your answer.  1.2. What is the ratio of the Value added (% of GDP) of Sudan in 2003 to that in 2006?
Your answer should be very brief. 0.93. What is the ratio of the Value added (% of GDP) in Uganda in 2003 to that in 2006?
Give a very brief answer. 0.99. What is the ratio of the Value added (% of GDP) in Colombia in 2003 to that in 2007?
Ensure brevity in your answer.  1.02. What is the ratio of the Value added (% of GDP) in Eritrea in 2003 to that in 2007?
Give a very brief answer. 1.2. What is the ratio of the Value added (% of GDP) in Sudan in 2003 to that in 2007?
Provide a succinct answer. 0.92. What is the ratio of the Value added (% of GDP) in Uganda in 2003 to that in 2007?
Provide a succinct answer. 1. What is the ratio of the Value added (% of GDP) in Colombia in 2003 to that in 2008?
Offer a very short reply. 1.05. What is the ratio of the Value added (% of GDP) in Eritrea in 2003 to that in 2008?
Offer a terse response. 1.18. What is the ratio of the Value added (% of GDP) of Sudan in 2003 to that in 2008?
Offer a very short reply. 0.97. What is the ratio of the Value added (% of GDP) of Eritrea in 2004 to that in 2005?
Offer a very short reply. 1.25. What is the ratio of the Value added (% of GDP) in Sudan in 2004 to that in 2005?
Give a very brief answer. 0.97. What is the ratio of the Value added (% of GDP) of Uganda in 2004 to that in 2005?
Keep it short and to the point. 1.14. What is the ratio of the Value added (% of GDP) of Colombia in 2004 to that in 2006?
Offer a terse response. 1.02. What is the ratio of the Value added (% of GDP) of Eritrea in 2004 to that in 2006?
Offer a terse response. 1.23. What is the ratio of the Value added (% of GDP) of Sudan in 2004 to that in 2006?
Give a very brief answer. 0.93. What is the ratio of the Value added (% of GDP) in Uganda in 2004 to that in 2006?
Ensure brevity in your answer.  1.1. What is the ratio of the Value added (% of GDP) of Colombia in 2004 to that in 2007?
Provide a succinct answer. 1.01. What is the ratio of the Value added (% of GDP) of Eritrea in 2004 to that in 2007?
Provide a short and direct response. 1.23. What is the ratio of the Value added (% of GDP) in Sudan in 2004 to that in 2007?
Offer a terse response. 0.93. What is the ratio of the Value added (% of GDP) of Uganda in 2004 to that in 2007?
Make the answer very short. 1.11. What is the ratio of the Value added (% of GDP) in Colombia in 2004 to that in 2008?
Give a very brief answer. 1.04. What is the ratio of the Value added (% of GDP) of Eritrea in 2004 to that in 2008?
Your answer should be very brief. 1.2. What is the ratio of the Value added (% of GDP) in Sudan in 2004 to that in 2008?
Offer a very short reply. 0.97. What is the ratio of the Value added (% of GDP) in Uganda in 2004 to that in 2008?
Your answer should be compact. 1.1. What is the ratio of the Value added (% of GDP) of Colombia in 2005 to that in 2006?
Ensure brevity in your answer.  1.01. What is the ratio of the Value added (% of GDP) in Eritrea in 2005 to that in 2006?
Give a very brief answer. 0.99. What is the ratio of the Value added (% of GDP) in Sudan in 2005 to that in 2006?
Offer a very short reply. 0.96. What is the ratio of the Value added (% of GDP) in Uganda in 2005 to that in 2006?
Offer a terse response. 0.96. What is the ratio of the Value added (% of GDP) in Eritrea in 2005 to that in 2007?
Provide a short and direct response. 0.99. What is the ratio of the Value added (% of GDP) of Sudan in 2005 to that in 2007?
Your response must be concise. 0.95. What is the ratio of the Value added (% of GDP) of Uganda in 2005 to that in 2007?
Your response must be concise. 0.97. What is the ratio of the Value added (% of GDP) of Colombia in 2005 to that in 2008?
Offer a very short reply. 1.03. What is the ratio of the Value added (% of GDP) of Eritrea in 2005 to that in 2008?
Provide a short and direct response. 0.97. What is the ratio of the Value added (% of GDP) in Uganda in 2005 to that in 2008?
Offer a terse response. 0.97. What is the ratio of the Value added (% of GDP) in Colombia in 2006 to that in 2007?
Keep it short and to the point. 0.99. What is the ratio of the Value added (% of GDP) in Eritrea in 2006 to that in 2007?
Keep it short and to the point. 1. What is the ratio of the Value added (% of GDP) in Colombia in 2006 to that in 2008?
Your answer should be compact. 1.02. What is the ratio of the Value added (% of GDP) in Eritrea in 2006 to that in 2008?
Ensure brevity in your answer.  0.98. What is the ratio of the Value added (% of GDP) in Sudan in 2006 to that in 2008?
Give a very brief answer. 1.04. What is the ratio of the Value added (% of GDP) in Sudan in 2007 to that in 2008?
Your answer should be very brief. 1.05. What is the ratio of the Value added (% of GDP) of Uganda in 2007 to that in 2008?
Keep it short and to the point. 1. What is the difference between the highest and the second highest Value added (% of GDP) in Colombia?
Keep it short and to the point. 1.45. What is the difference between the highest and the second highest Value added (% of GDP) of Eritrea?
Your answer should be compact. 1.4. What is the difference between the highest and the second highest Value added (% of GDP) in Sudan?
Provide a short and direct response. 0.27. What is the difference between the highest and the second highest Value added (% of GDP) of Uganda?
Provide a succinct answer. 4.28. What is the difference between the highest and the lowest Value added (% of GDP) in Colombia?
Make the answer very short. 4.04. What is the difference between the highest and the lowest Value added (% of GDP) in Eritrea?
Make the answer very short. 13.22. What is the difference between the highest and the lowest Value added (% of GDP) of Sudan?
Provide a short and direct response. 5.1. What is the difference between the highest and the lowest Value added (% of GDP) in Uganda?
Your answer should be compact. 6.76. 